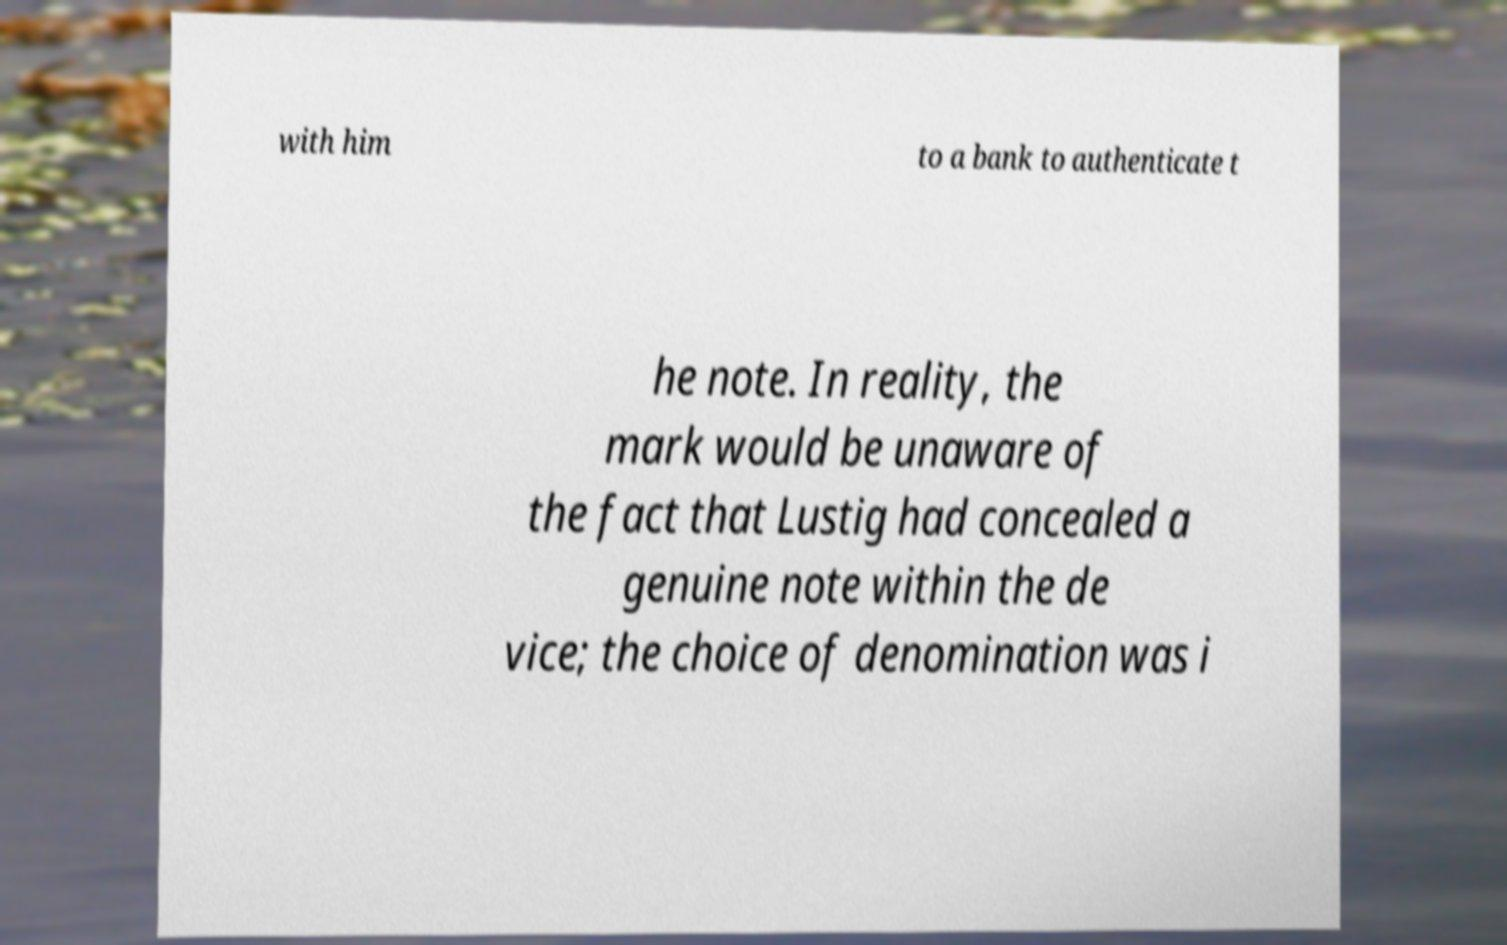I need the written content from this picture converted into text. Can you do that? with him to a bank to authenticate t he note. In reality, the mark would be unaware of the fact that Lustig had concealed a genuine note within the de vice; the choice of denomination was i 